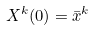<formula> <loc_0><loc_0><loc_500><loc_500>X ^ { k } ( 0 ) = \bar { x } ^ { k }</formula> 